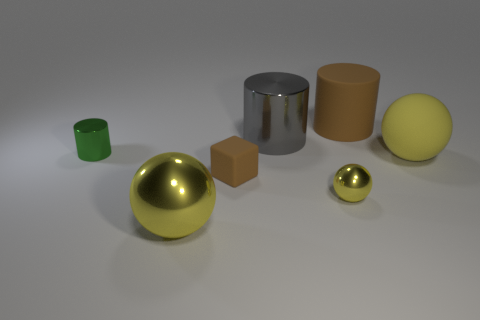Add 1 yellow metal balls. How many objects exist? 8 Subtract all cylinders. How many objects are left? 4 Subtract 0 gray cubes. How many objects are left? 7 Subtract all tiny red cylinders. Subtract all tiny green things. How many objects are left? 6 Add 7 big gray metallic things. How many big gray metallic things are left? 8 Add 1 tiny things. How many tiny things exist? 4 